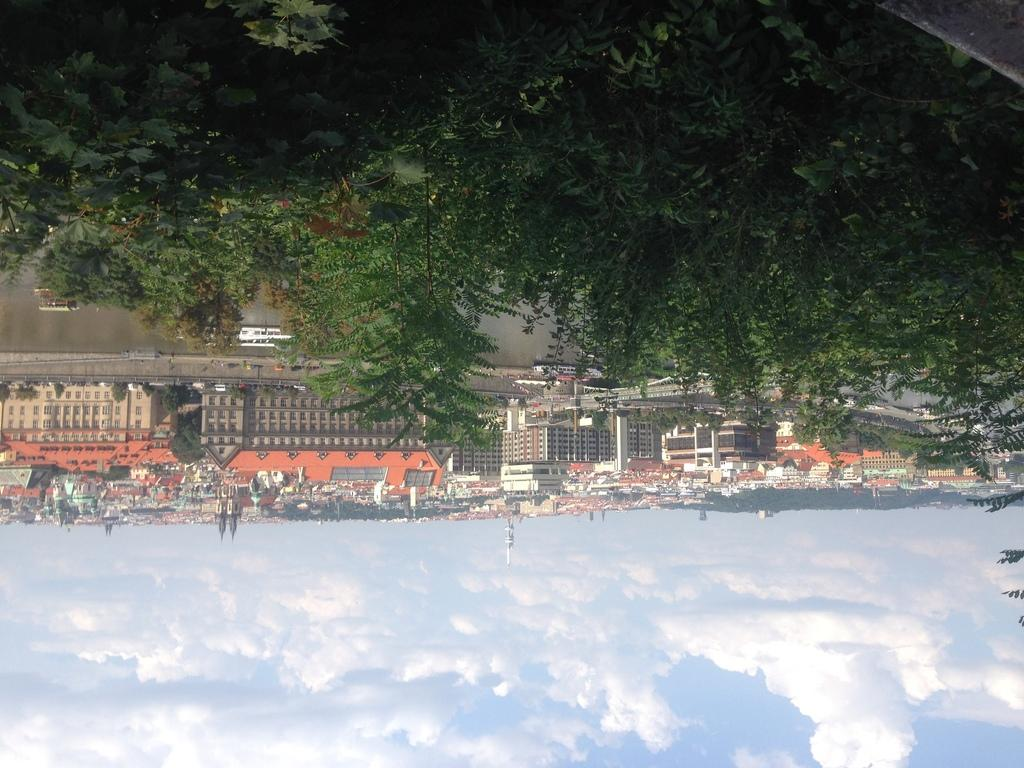What type of natural environment is depicted in the image? There are many trees in the image, suggesting a forest or wooded area. What type of watercraft can be seen in the image? There are boats on the water in the image. What type of structures can be seen in the background of the image? There are buildings in the background of the image. What is visible in the sky in the image? There are clouds and the sky visible in the background of the image. What type of glue is being used to hold the trees together in the image? There is no glue present in the image; the trees are naturally growing in the depicted environment. 